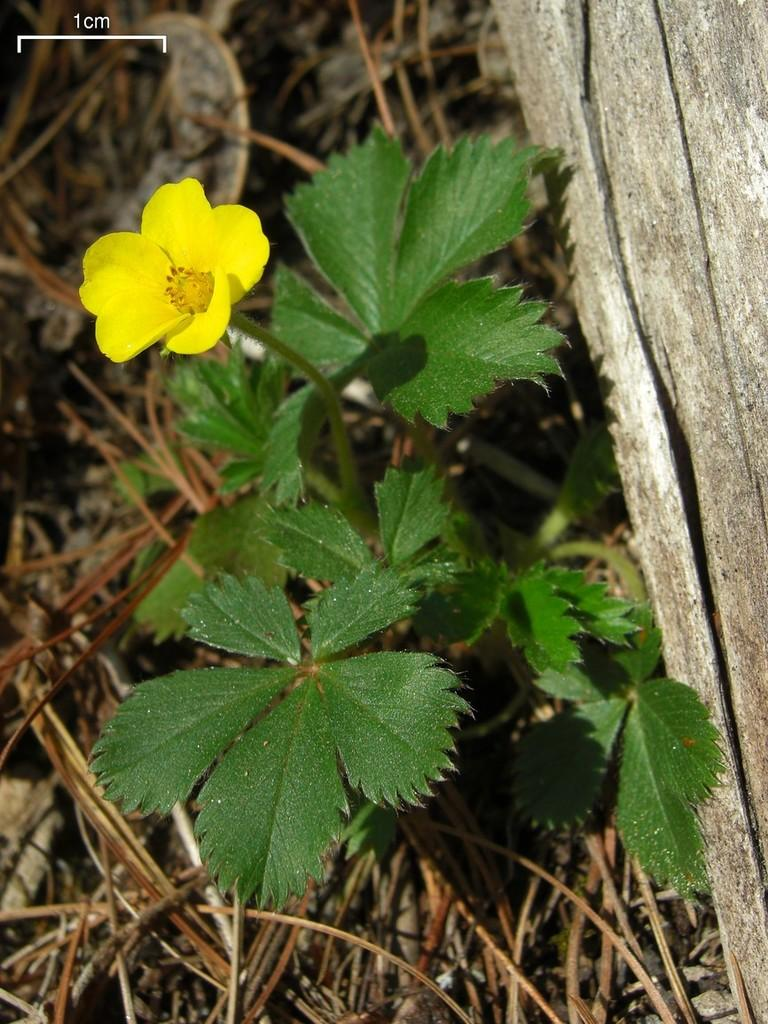What type of plant is visible in the image? There is a plant with a yellow flower in the image. What is the condition of the grass surrounding the plant? The grass around the plant is dry. What material is the object on the right side of the image made of? The object on the right side of the image is made of wood. How many tomatoes are growing on the plant in the image? There are no tomatoes present in the image; it features a plant with a yellow flower. What type of paste is being applied to the wooden object in the image? There is no paste being applied to the wooden object in the image; it is a standalone object made of wood. 